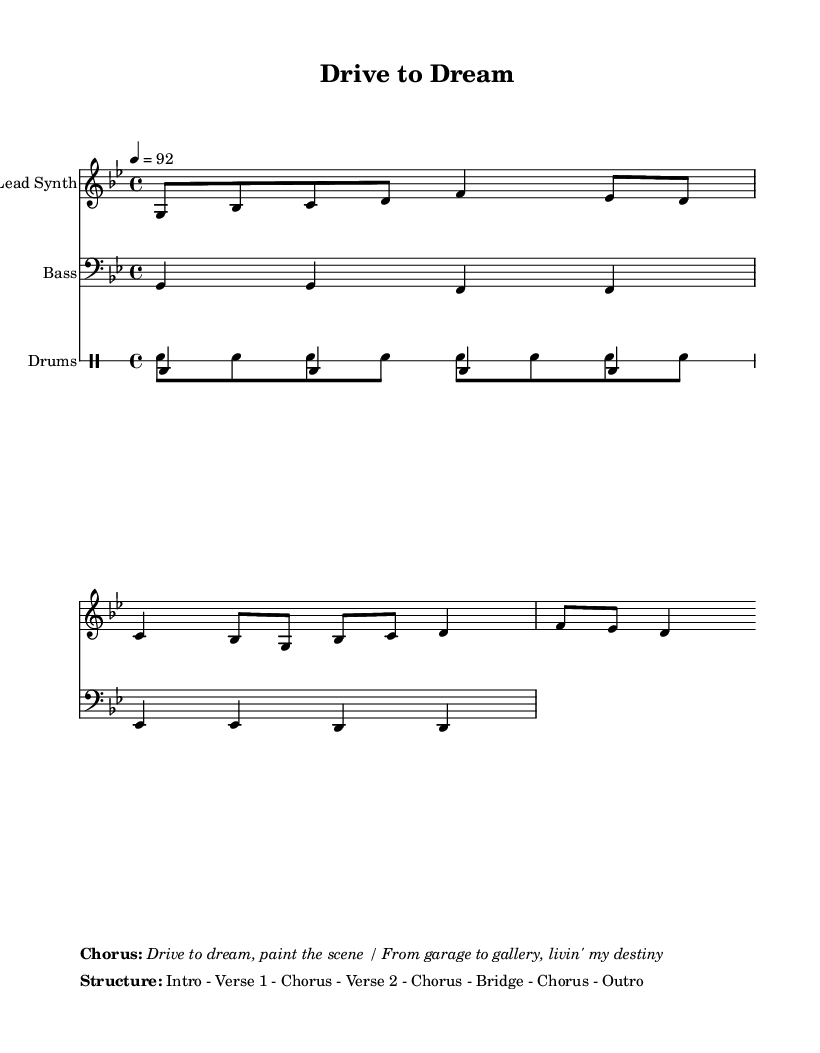What is the key signature of this music? The key signature is G minor, which has two flats: B flat and E flat. You can determine this from the key indicated at the beginning of the score.
Answer: G minor What is the time signature of this music? The time signature is 4/4, shown at the beginning of the score. This means there are four beats per measure, and the quarter note gets one beat.
Answer: 4/4 What is the tempo marking indicated in the music? The tempo marking is a quarter note equals 92 beats per minute, which can be found next to the tempo indication at the start of the score.
Answer: 92 How many verses are in the structure of the song? The structure includes two verses, as detailed in the "Structure" section at the bottom of the score that labels "Verse 1" and "Verse 2."
Answer: 2 What is the main theme of the lyrics in the song? The main theme of the lyrics is about pursuing your creative dreams and driving towards success, which is evident from the lyrics that talk about the journey and effort involved.
Answer: Pursuing dreams What is the role of the drum pattern in this piece? The drum pattern in this piece primarily provides an upbeat and driving rhythm, serving to energize the rap and support the vocal delivery. This is clear from the drum staff that features both kick and snare patterns.
Answer: Driving rhythm What does the chorus of the song emphasize? The chorus emphasizes the determination to achieve one's dreams and the transition from a humble beginning (garage) to success (gallery), as indicated in the extracted chorus lyrics.
Answer: Drive to dream 